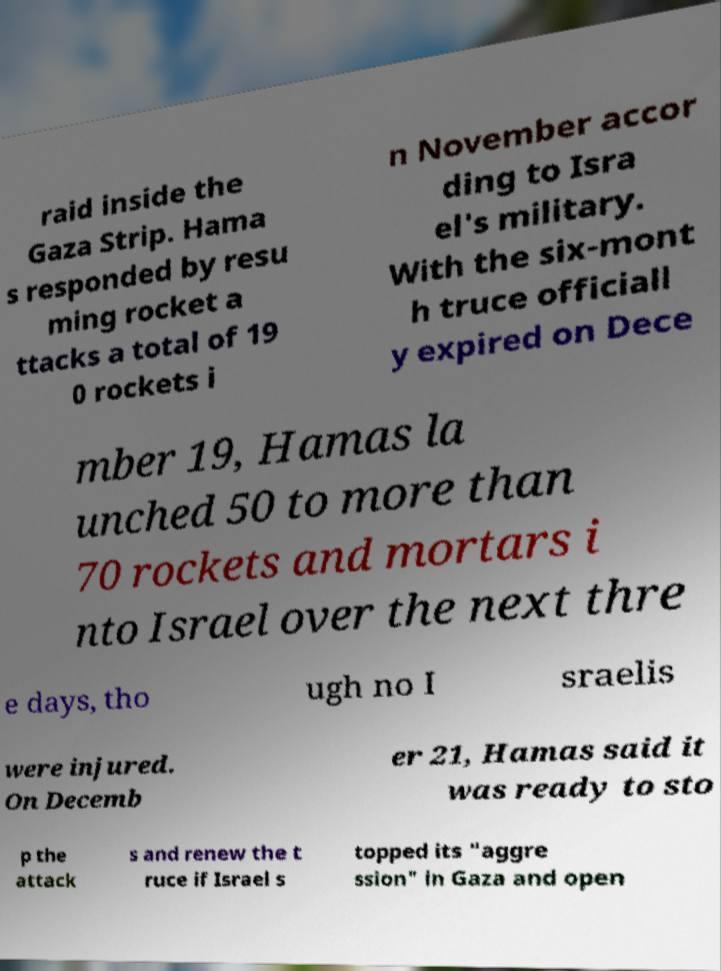Can you accurately transcribe the text from the provided image for me? raid inside the Gaza Strip. Hama s responded by resu ming rocket a ttacks a total of 19 0 rockets i n November accor ding to Isra el's military. With the six-mont h truce officiall y expired on Dece mber 19, Hamas la unched 50 to more than 70 rockets and mortars i nto Israel over the next thre e days, tho ugh no I sraelis were injured. On Decemb er 21, Hamas said it was ready to sto p the attack s and renew the t ruce if Israel s topped its "aggre ssion" in Gaza and open 